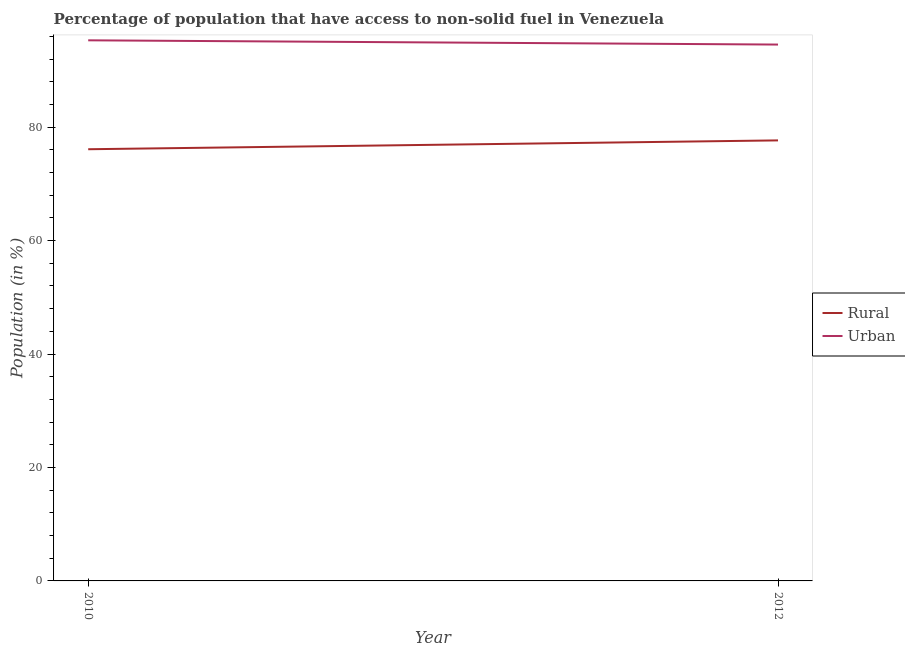What is the urban population in 2012?
Offer a very short reply. 94.57. Across all years, what is the maximum urban population?
Provide a short and direct response. 95.32. Across all years, what is the minimum urban population?
Ensure brevity in your answer.  94.57. In which year was the rural population maximum?
Keep it short and to the point. 2012. What is the total urban population in the graph?
Keep it short and to the point. 189.88. What is the difference between the urban population in 2010 and that in 2012?
Your answer should be compact. 0.75. What is the difference between the rural population in 2012 and the urban population in 2010?
Keep it short and to the point. -17.64. What is the average rural population per year?
Ensure brevity in your answer.  76.89. In the year 2010, what is the difference between the urban population and rural population?
Offer a terse response. 19.2. In how many years, is the urban population greater than 32 %?
Ensure brevity in your answer.  2. What is the ratio of the rural population in 2010 to that in 2012?
Offer a very short reply. 0.98. Is the rural population in 2010 less than that in 2012?
Your answer should be very brief. Yes. In how many years, is the urban population greater than the average urban population taken over all years?
Your answer should be compact. 1. How many lines are there?
Ensure brevity in your answer.  2. How many years are there in the graph?
Provide a succinct answer. 2. What is the difference between two consecutive major ticks on the Y-axis?
Your answer should be very brief. 20. Are the values on the major ticks of Y-axis written in scientific E-notation?
Offer a terse response. No. Does the graph contain any zero values?
Make the answer very short. No. Does the graph contain grids?
Keep it short and to the point. No. How are the legend labels stacked?
Your answer should be very brief. Vertical. What is the title of the graph?
Provide a succinct answer. Percentage of population that have access to non-solid fuel in Venezuela. Does "Taxes on profits and capital gains" appear as one of the legend labels in the graph?
Give a very brief answer. No. What is the label or title of the Y-axis?
Provide a succinct answer. Population (in %). What is the Population (in %) of Rural in 2010?
Provide a succinct answer. 76.11. What is the Population (in %) in Urban in 2010?
Give a very brief answer. 95.32. What is the Population (in %) of Rural in 2012?
Keep it short and to the point. 77.67. What is the Population (in %) in Urban in 2012?
Make the answer very short. 94.57. Across all years, what is the maximum Population (in %) in Rural?
Provide a succinct answer. 77.67. Across all years, what is the maximum Population (in %) in Urban?
Give a very brief answer. 95.32. Across all years, what is the minimum Population (in %) in Rural?
Give a very brief answer. 76.11. Across all years, what is the minimum Population (in %) of Urban?
Give a very brief answer. 94.57. What is the total Population (in %) in Rural in the graph?
Ensure brevity in your answer.  153.78. What is the total Population (in %) in Urban in the graph?
Your answer should be compact. 189.88. What is the difference between the Population (in %) in Rural in 2010 and that in 2012?
Provide a succinct answer. -1.56. What is the difference between the Population (in %) of Urban in 2010 and that in 2012?
Your response must be concise. 0.75. What is the difference between the Population (in %) in Rural in 2010 and the Population (in %) in Urban in 2012?
Your answer should be compact. -18.45. What is the average Population (in %) of Rural per year?
Your answer should be compact. 76.89. What is the average Population (in %) of Urban per year?
Your answer should be compact. 94.94. In the year 2010, what is the difference between the Population (in %) of Rural and Population (in %) of Urban?
Offer a very short reply. -19.2. In the year 2012, what is the difference between the Population (in %) in Rural and Population (in %) in Urban?
Give a very brief answer. -16.9. What is the ratio of the Population (in %) of Rural in 2010 to that in 2012?
Your answer should be very brief. 0.98. What is the ratio of the Population (in %) of Urban in 2010 to that in 2012?
Offer a terse response. 1.01. What is the difference between the highest and the second highest Population (in %) of Rural?
Provide a succinct answer. 1.56. What is the difference between the highest and the second highest Population (in %) of Urban?
Your answer should be compact. 0.75. What is the difference between the highest and the lowest Population (in %) in Rural?
Make the answer very short. 1.56. What is the difference between the highest and the lowest Population (in %) of Urban?
Offer a very short reply. 0.75. 